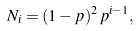<formula> <loc_0><loc_0><loc_500><loc_500>N _ { i } = ( 1 - p ) ^ { 2 } \, p ^ { i - 1 } ,</formula> 